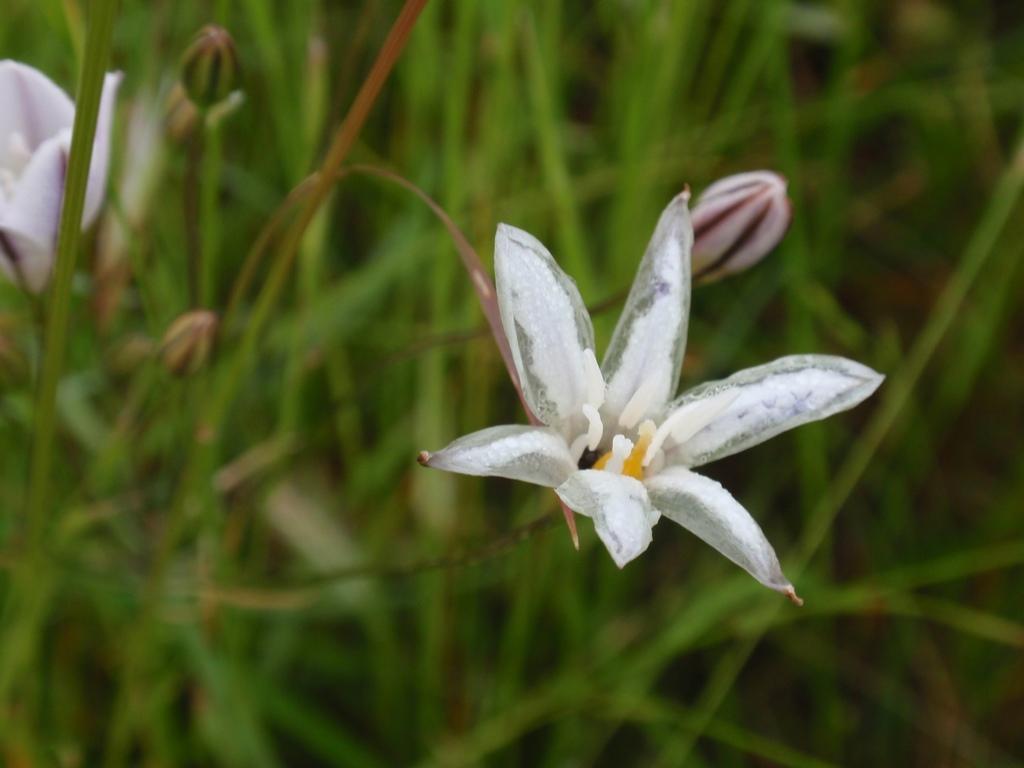Could you give a brief overview of what you see in this image? In this image I can see there are flowers, buds and plants. 